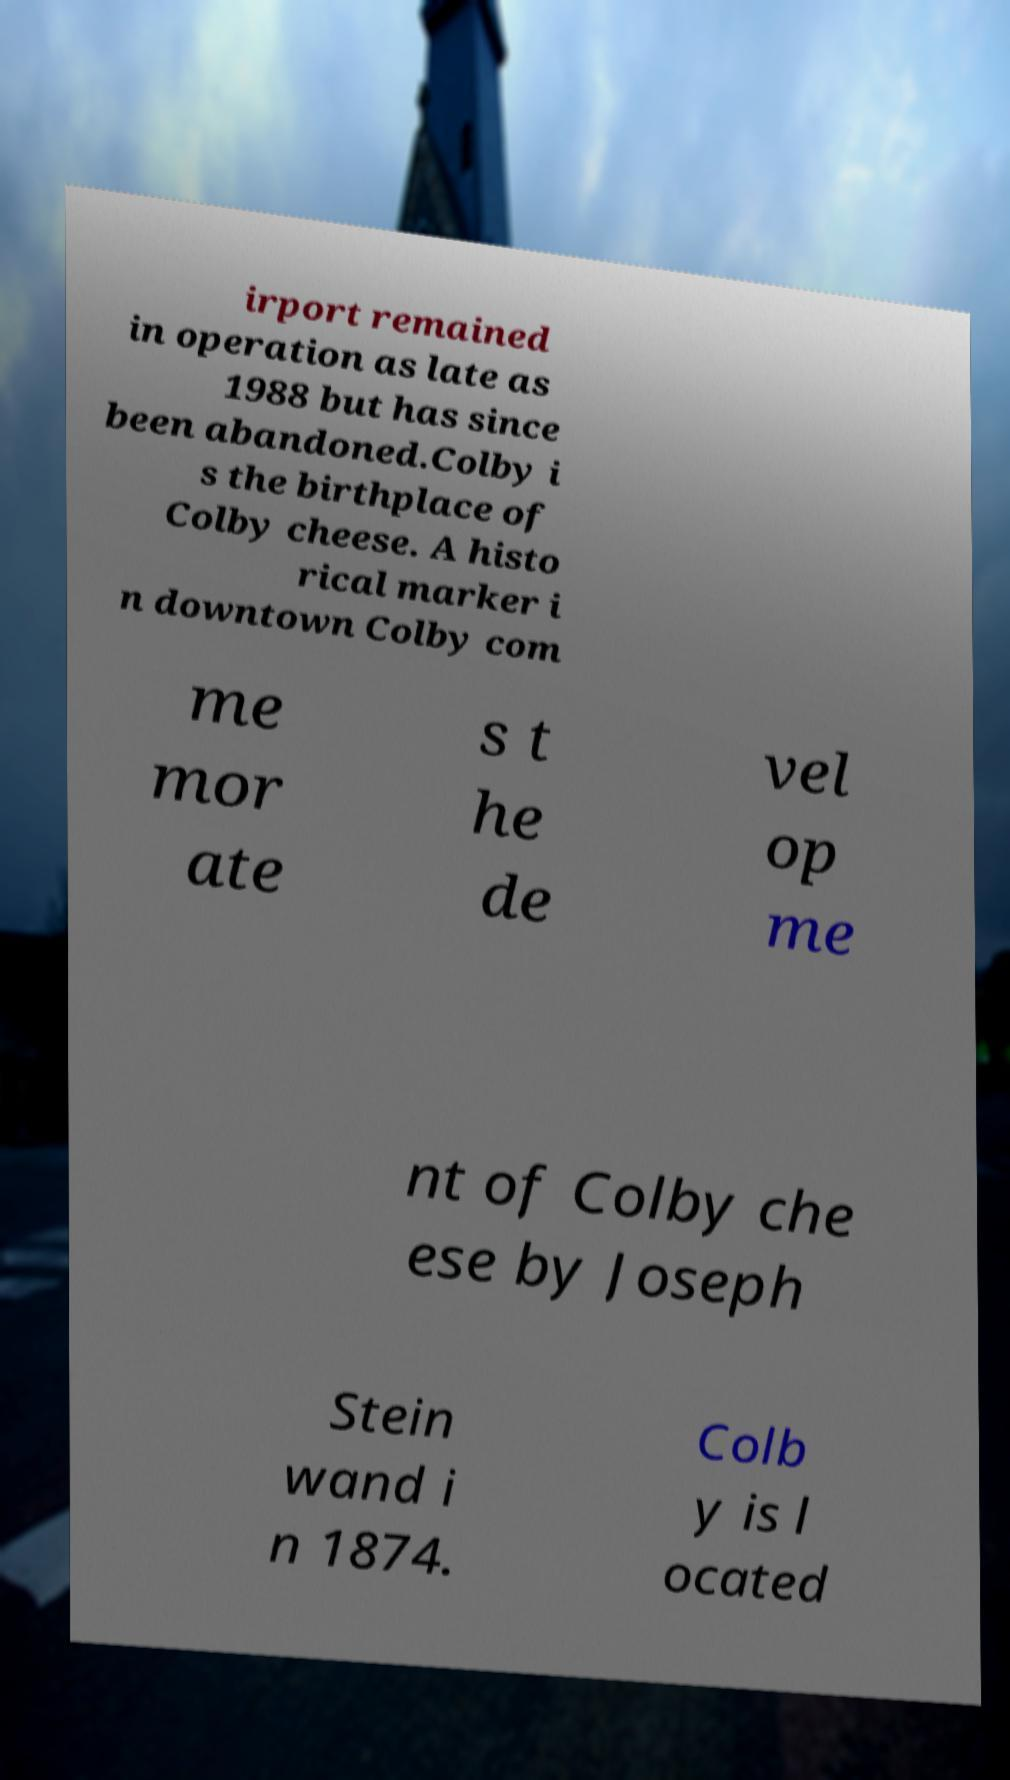Please identify and transcribe the text found in this image. irport remained in operation as late as 1988 but has since been abandoned.Colby i s the birthplace of Colby cheese. A histo rical marker i n downtown Colby com me mor ate s t he de vel op me nt of Colby che ese by Joseph Stein wand i n 1874. Colb y is l ocated 